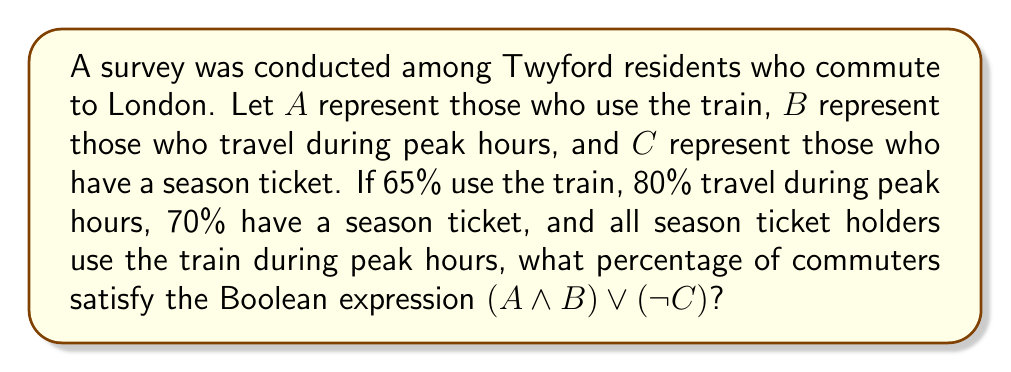Provide a solution to this math problem. Let's approach this step-by-step:

1) First, let's consider the given information:
   $P(A) = 0.65$ (65% use the train)
   $P(B) = 0.80$ (80% travel during peak hours)
   $P(C) = 0.70$ (70% have a season ticket)
   $P(C) = P(A \land B \land C)$ (all season ticket holders use the train during peak hours)

2) We need to find $P((A \land B) \lor (\lnot C))$

3) Using De Morgan's law, we can rewrite this as:
   $P((A \land B) \lor (\lnot C)) = 1 - P((\lnot(A \land B)) \land C)$

4) We know that $P(C) = P(A \land B \land C)$, so:
   $P((\lnot(A \land B)) \land C) = 0$

5) Therefore:
   $P((A \land B) \lor (\lnot C)) = 1 - 0 = 1$

6) Converting to a percentage:
   $1 * 100\% = 100\%$

Thus, 100% of commuters satisfy the given Boolean expression.
Answer: 100% 